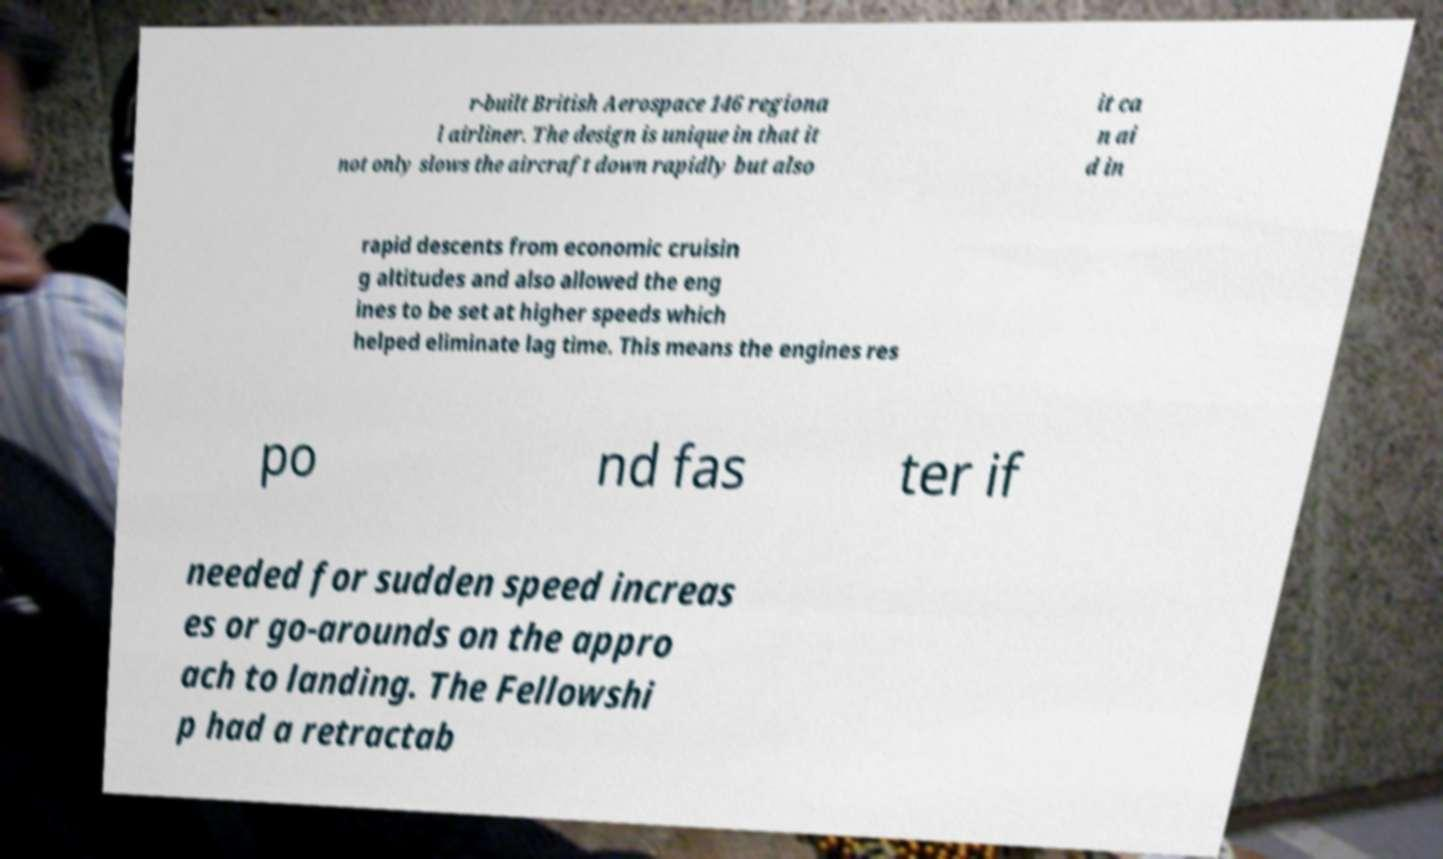Please read and relay the text visible in this image. What does it say? r-built British Aerospace 146 regiona l airliner. The design is unique in that it not only slows the aircraft down rapidly but also it ca n ai d in rapid descents from economic cruisin g altitudes and also allowed the eng ines to be set at higher speeds which helped eliminate lag time. This means the engines res po nd fas ter if needed for sudden speed increas es or go-arounds on the appro ach to landing. The Fellowshi p had a retractab 